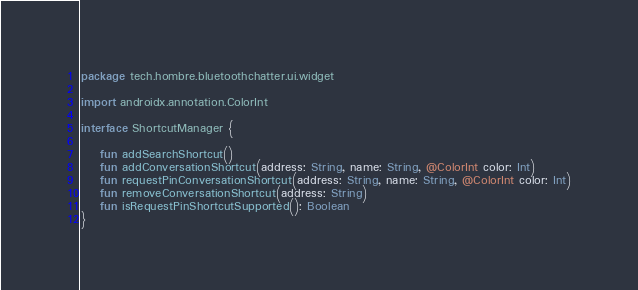Convert code to text. <code><loc_0><loc_0><loc_500><loc_500><_Kotlin_>package tech.hombre.bluetoothchatter.ui.widget

import androidx.annotation.ColorInt

interface ShortcutManager {

    fun addSearchShortcut()
    fun addConversationShortcut(address: String, name: String, @ColorInt color: Int)
    fun requestPinConversationShortcut(address: String, name: String, @ColorInt color: Int)
    fun removeConversationShortcut(address: String)
    fun isRequestPinShortcutSupported(): Boolean
}
</code> 